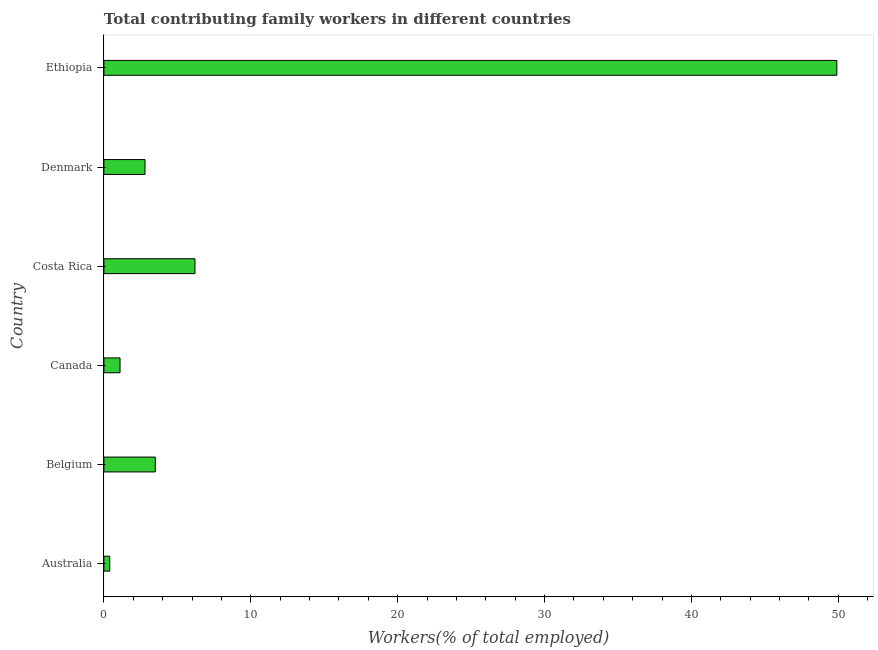Does the graph contain any zero values?
Make the answer very short. No. What is the title of the graph?
Provide a short and direct response. Total contributing family workers in different countries. What is the label or title of the X-axis?
Your response must be concise. Workers(% of total employed). What is the label or title of the Y-axis?
Your answer should be very brief. Country. What is the contributing family workers in Canada?
Ensure brevity in your answer.  1.1. Across all countries, what is the maximum contributing family workers?
Give a very brief answer. 49.9. Across all countries, what is the minimum contributing family workers?
Keep it short and to the point. 0.4. In which country was the contributing family workers maximum?
Provide a succinct answer. Ethiopia. What is the sum of the contributing family workers?
Offer a very short reply. 63.9. What is the average contributing family workers per country?
Give a very brief answer. 10.65. What is the median contributing family workers?
Ensure brevity in your answer.  3.15. What is the ratio of the contributing family workers in Australia to that in Canada?
Give a very brief answer. 0.36. Is the contributing family workers in Australia less than that in Ethiopia?
Offer a terse response. Yes. Is the difference between the contributing family workers in Australia and Canada greater than the difference between any two countries?
Provide a succinct answer. No. What is the difference between the highest and the second highest contributing family workers?
Provide a short and direct response. 43.7. Is the sum of the contributing family workers in Canada and Ethiopia greater than the maximum contributing family workers across all countries?
Your response must be concise. Yes. What is the difference between the highest and the lowest contributing family workers?
Keep it short and to the point. 49.5. How many bars are there?
Offer a terse response. 6. How many countries are there in the graph?
Offer a terse response. 6. What is the difference between two consecutive major ticks on the X-axis?
Offer a terse response. 10. Are the values on the major ticks of X-axis written in scientific E-notation?
Your response must be concise. No. What is the Workers(% of total employed) of Australia?
Provide a short and direct response. 0.4. What is the Workers(% of total employed) in Canada?
Provide a succinct answer. 1.1. What is the Workers(% of total employed) of Costa Rica?
Provide a succinct answer. 6.2. What is the Workers(% of total employed) of Denmark?
Ensure brevity in your answer.  2.8. What is the Workers(% of total employed) of Ethiopia?
Offer a very short reply. 49.9. What is the difference between the Workers(% of total employed) in Australia and Canada?
Your response must be concise. -0.7. What is the difference between the Workers(% of total employed) in Australia and Denmark?
Give a very brief answer. -2.4. What is the difference between the Workers(% of total employed) in Australia and Ethiopia?
Keep it short and to the point. -49.5. What is the difference between the Workers(% of total employed) in Belgium and Canada?
Offer a very short reply. 2.4. What is the difference between the Workers(% of total employed) in Belgium and Costa Rica?
Give a very brief answer. -2.7. What is the difference between the Workers(% of total employed) in Belgium and Denmark?
Give a very brief answer. 0.7. What is the difference between the Workers(% of total employed) in Belgium and Ethiopia?
Make the answer very short. -46.4. What is the difference between the Workers(% of total employed) in Canada and Costa Rica?
Make the answer very short. -5.1. What is the difference between the Workers(% of total employed) in Canada and Ethiopia?
Keep it short and to the point. -48.8. What is the difference between the Workers(% of total employed) in Costa Rica and Denmark?
Offer a very short reply. 3.4. What is the difference between the Workers(% of total employed) in Costa Rica and Ethiopia?
Offer a terse response. -43.7. What is the difference between the Workers(% of total employed) in Denmark and Ethiopia?
Your answer should be compact. -47.1. What is the ratio of the Workers(% of total employed) in Australia to that in Belgium?
Offer a terse response. 0.11. What is the ratio of the Workers(% of total employed) in Australia to that in Canada?
Your response must be concise. 0.36. What is the ratio of the Workers(% of total employed) in Australia to that in Costa Rica?
Make the answer very short. 0.07. What is the ratio of the Workers(% of total employed) in Australia to that in Denmark?
Provide a succinct answer. 0.14. What is the ratio of the Workers(% of total employed) in Australia to that in Ethiopia?
Offer a very short reply. 0.01. What is the ratio of the Workers(% of total employed) in Belgium to that in Canada?
Your answer should be very brief. 3.18. What is the ratio of the Workers(% of total employed) in Belgium to that in Costa Rica?
Your answer should be compact. 0.56. What is the ratio of the Workers(% of total employed) in Belgium to that in Denmark?
Give a very brief answer. 1.25. What is the ratio of the Workers(% of total employed) in Belgium to that in Ethiopia?
Keep it short and to the point. 0.07. What is the ratio of the Workers(% of total employed) in Canada to that in Costa Rica?
Provide a succinct answer. 0.18. What is the ratio of the Workers(% of total employed) in Canada to that in Denmark?
Offer a very short reply. 0.39. What is the ratio of the Workers(% of total employed) in Canada to that in Ethiopia?
Your answer should be very brief. 0.02. What is the ratio of the Workers(% of total employed) in Costa Rica to that in Denmark?
Offer a very short reply. 2.21. What is the ratio of the Workers(% of total employed) in Costa Rica to that in Ethiopia?
Keep it short and to the point. 0.12. What is the ratio of the Workers(% of total employed) in Denmark to that in Ethiopia?
Offer a very short reply. 0.06. 